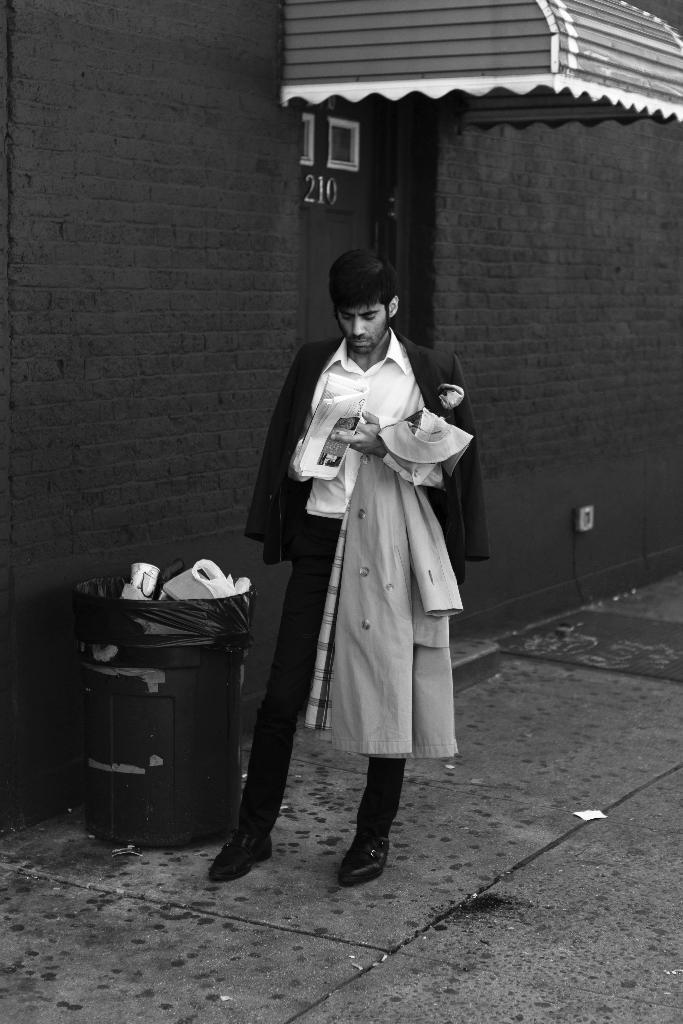In one or two sentences, can you explain what this image depicts? This is a black and white image and here we can see a person standing and holding papers and a coat and in the background, there is a building and we can see a door. At the bottom, there is bin with glasses and papers and there is road. 